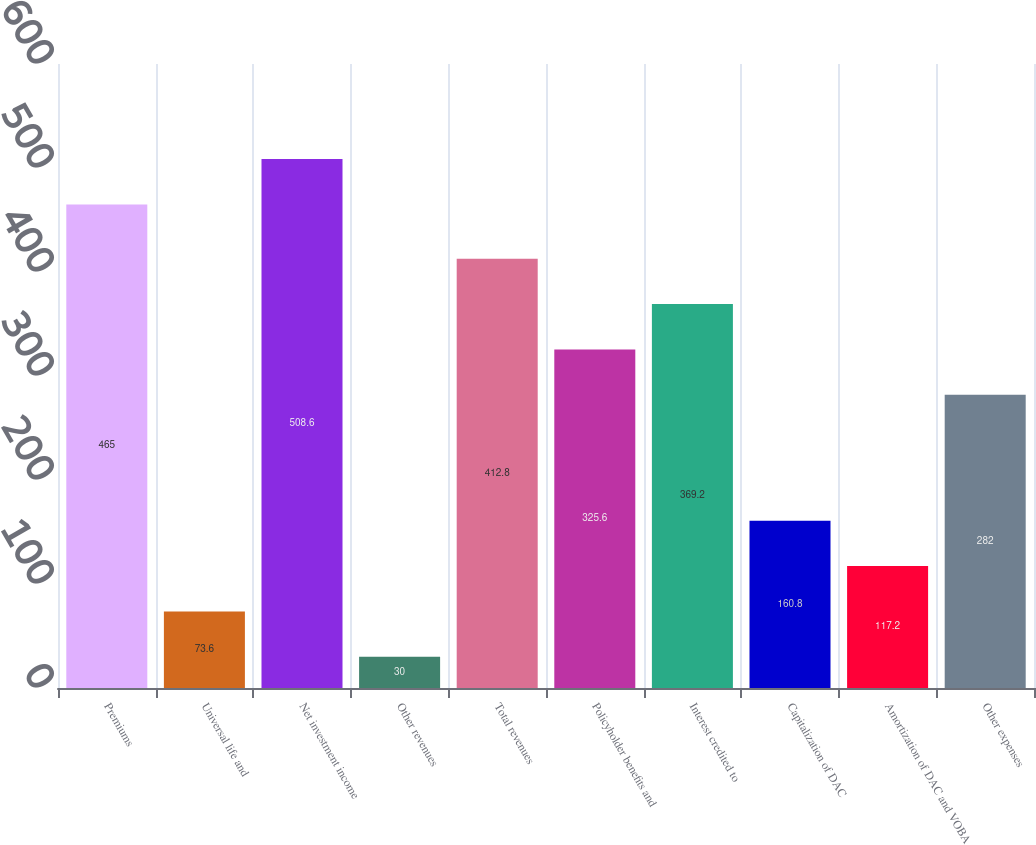Convert chart to OTSL. <chart><loc_0><loc_0><loc_500><loc_500><bar_chart><fcel>Premiums<fcel>Universal life and<fcel>Net investment income<fcel>Other revenues<fcel>Total revenues<fcel>Policyholder benefits and<fcel>Interest credited to<fcel>Capitalization of DAC<fcel>Amortization of DAC and VOBA<fcel>Other expenses<nl><fcel>465<fcel>73.6<fcel>508.6<fcel>30<fcel>412.8<fcel>325.6<fcel>369.2<fcel>160.8<fcel>117.2<fcel>282<nl></chart> 